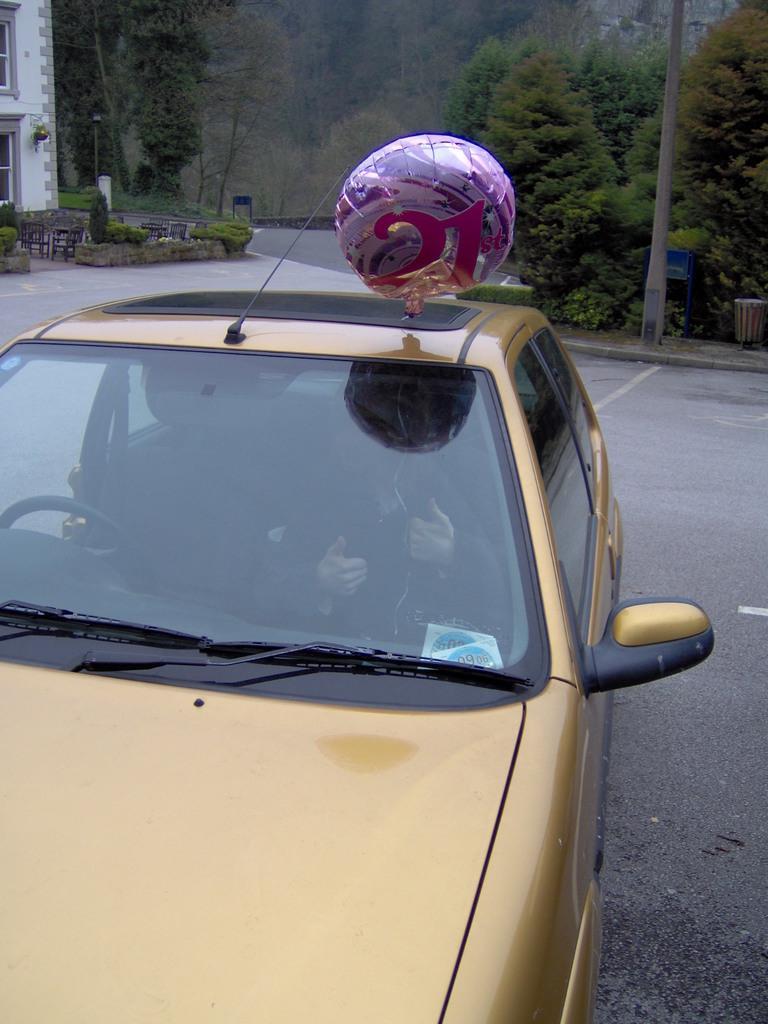Can you describe this image briefly? In this picture we can see a person is sitting in a car and at the top of the car, it looks like a balloon. Behind the car there are poles, boards, chairs, a building, trees and there is a road. 